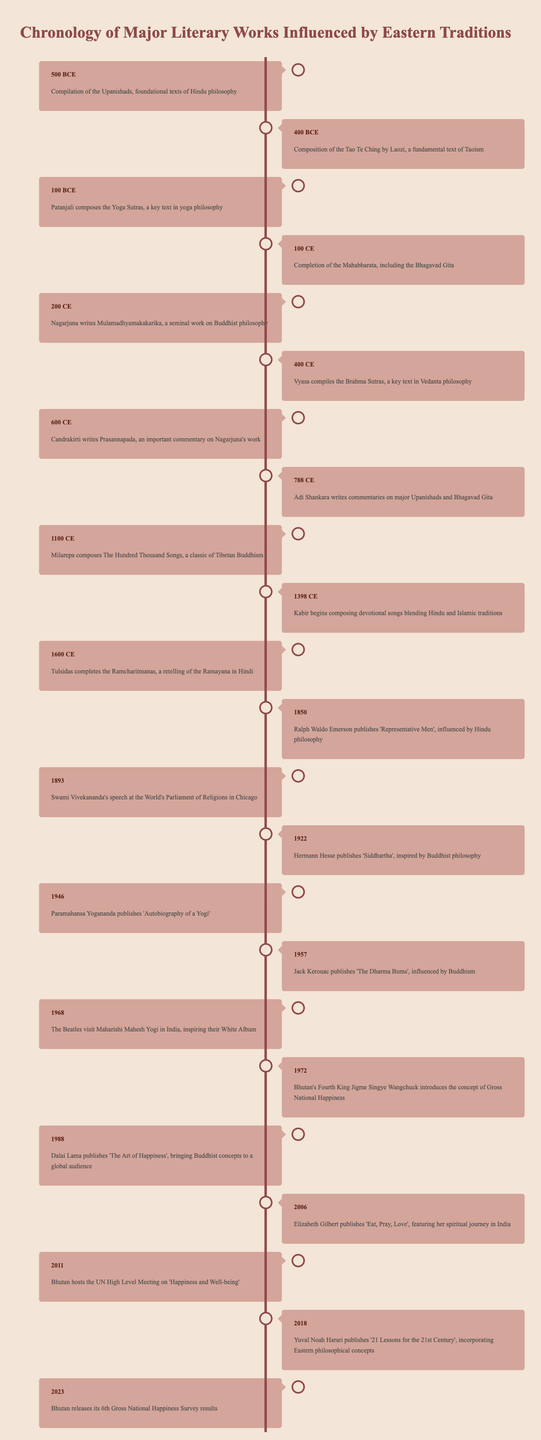What major work was completed in 100 CE? The timeline shows that in 100 CE, the completion of the Mahabharata, including the Bhagavad Gita, occurred. This is a direct retrieval from the table.
Answer: Mahabharata Which text was written by Laozi? According to the timeline, Laozi composed the Tao Te Ching, which is noted as a fundamental text of Taoism. This can be directly referred to from the table.
Answer: Tao Te Ching Was Kabir's work influenced by both Hindu and Islamic traditions? The table states that Kabir began composing devotional songs blending Hindu and Islamic traditions, confirming that his work reflects elements from both religions.
Answer: Yes How many significant events are listed in the timeline between 500 BCE and 200 CE? Counting the events from 500 BCE to 200 CE in the table, we find five significant entries: 500 BCE, 400 BCE, 100 BCE, 100 CE, and 200 CE. Thus, the total is 5.
Answer: 5 In which year was 'Siddhartha' published? The timeline indicates that 'Siddhartha' was published in 1922 by Hermann Hesse. This is a factual retrieval from the table.
Answer: 1922 Which author published a work related to Gross National Happiness? The table notes that Bhutan's Fourth King Jigme Singye Wangchuck introduced the concept of Gross National Happiness in 1972 and mentions Bhutan's release of its 6th Gross National Happiness Survey results in 2023; therefore, both are related to this concept.
Answer: Jigme Singye Wangchuck What is the earliest event mentioned in the timeline? The earliest event highlighted in the timeline is the compilation of the Upanishads, which took place in 500 BCE, and this is clearly stated in the table.
Answer: Compilation of the Upanishads Between which years were works on Buddhist philosophy notably published? The timeline shows several works related to Buddhist philosophy published between 200 CE (Nagarjuna writes Mulamadhyamakakarika) and 1922 (Hermann Hesse publishes 'Siddhartha'), covering a span of 1722 years of literary influence reflecting Buddhist thought. Thus, the answer covers both ends of the timeline.
Answer: 200 CE - 1922 What was the main focus of Elizabeth Gilbert's 'Eat, Pray, Love'? According to the table, 'Eat, Pray, Love', published in 2006, features Elizabeth Gilbert's spiritual journey in India, which is the main focus of the work, as stated directly in the timeline.
Answer: Spiritual journey in India 